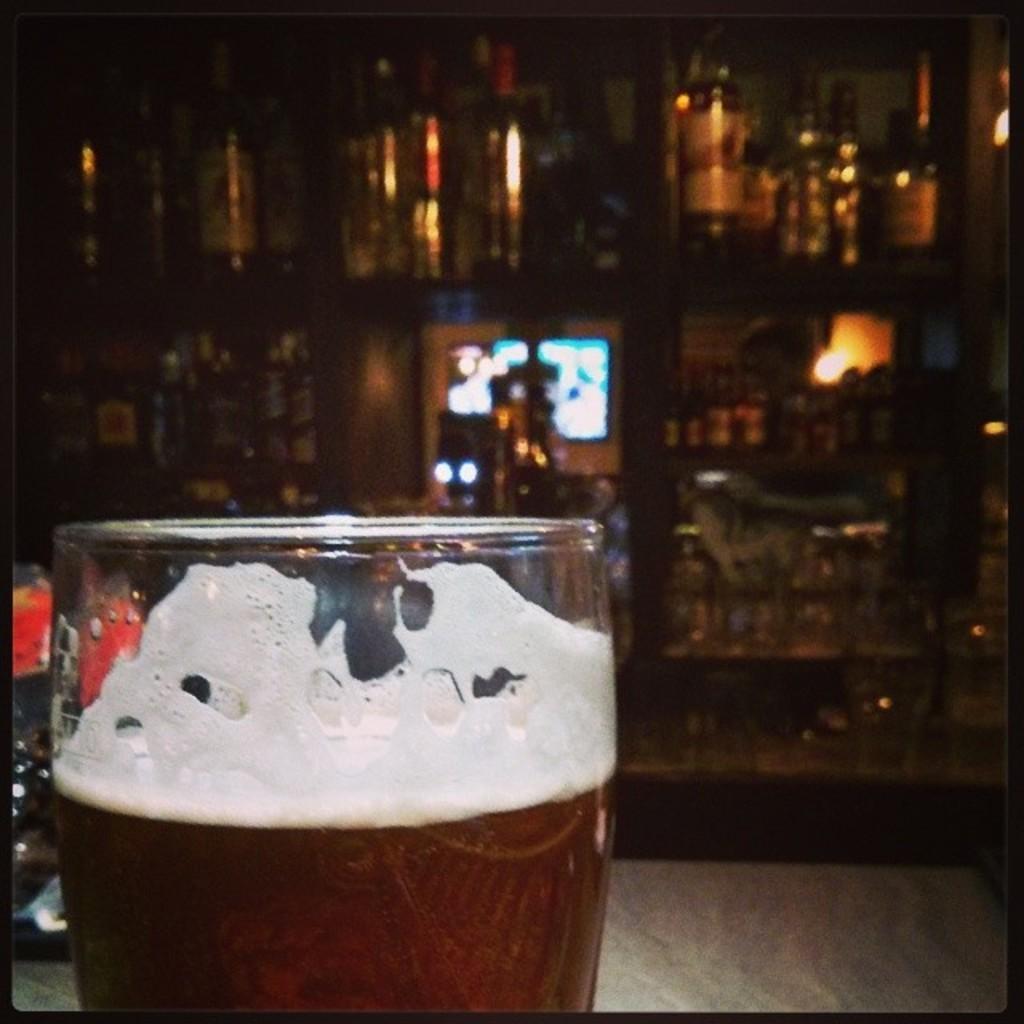Could you give a brief overview of what you see in this image? In this image there is a glass in the bottom left side of this image and there are some objects are kept in a shelf as we can see in middle of this image. 